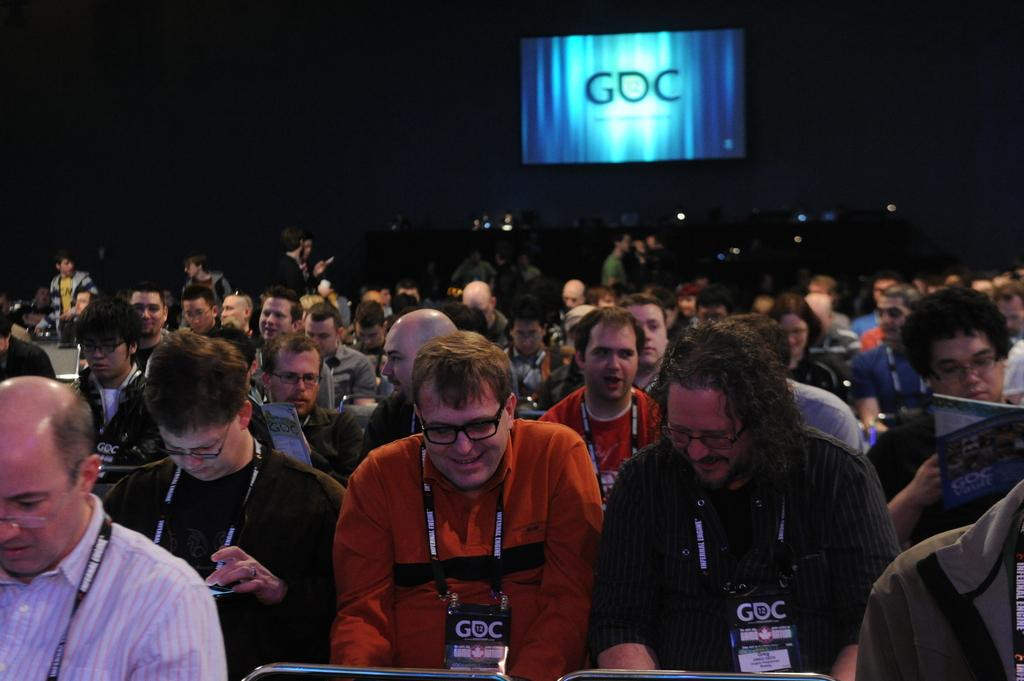What is the main subject of the image? The main subject of the image is a crowd. What can be seen in the image besides the crowd? There is a screen in the image. How would you describe the lighting in the image? The background of the image is dark. What type of drug can be seen in the hands of the people in the image? There is no drug present in the image; it only shows a crowd and a screen. What type of butter is being used to prepare the meal in the image? There is no meal or butter present in the image; it only shows a crowd and a screen. 